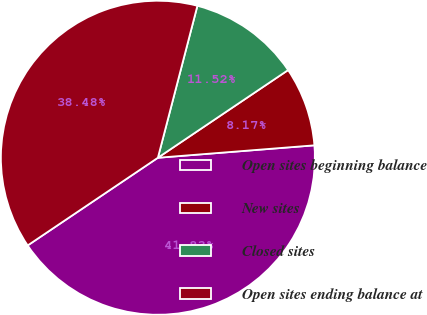Convert chart to OTSL. <chart><loc_0><loc_0><loc_500><loc_500><pie_chart><fcel>Open sites beginning balance<fcel>New sites<fcel>Closed sites<fcel>Open sites ending balance at<nl><fcel>41.83%<fcel>8.17%<fcel>11.52%<fcel>38.48%<nl></chart> 